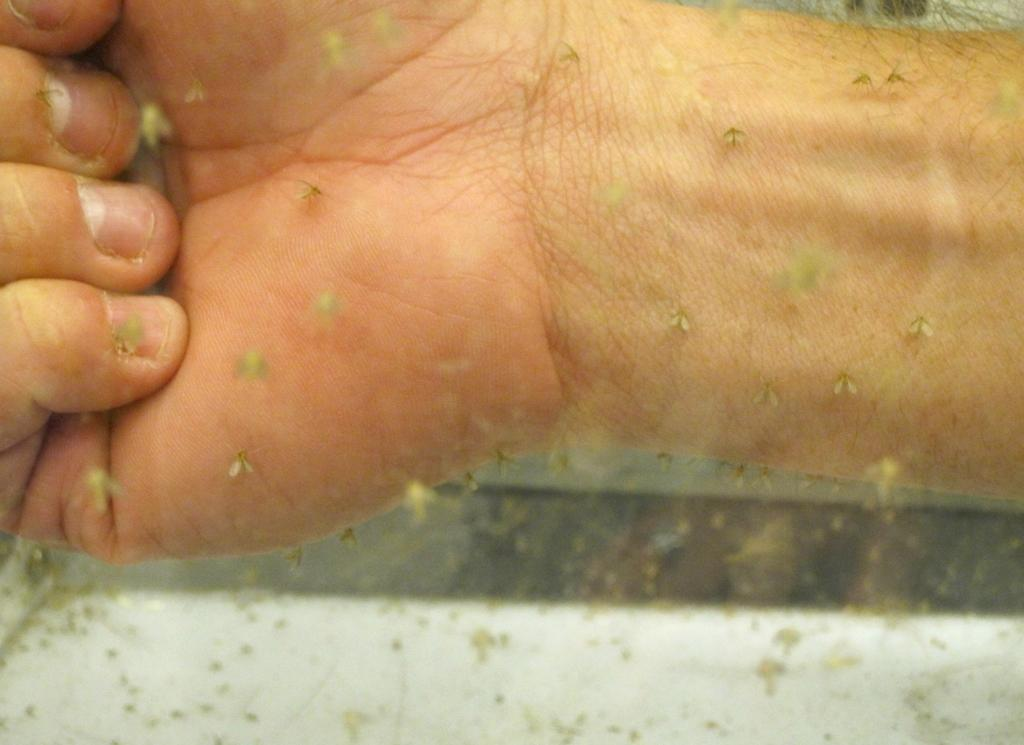What is happening on the person's hand in the image? There are insects on a person's hand in the image. Can you describe the possible background element in the image? The image may depict a glass door. How many times has the hydrant been folded in the image? There is no hydrant present in the image, so it cannot be folded. 